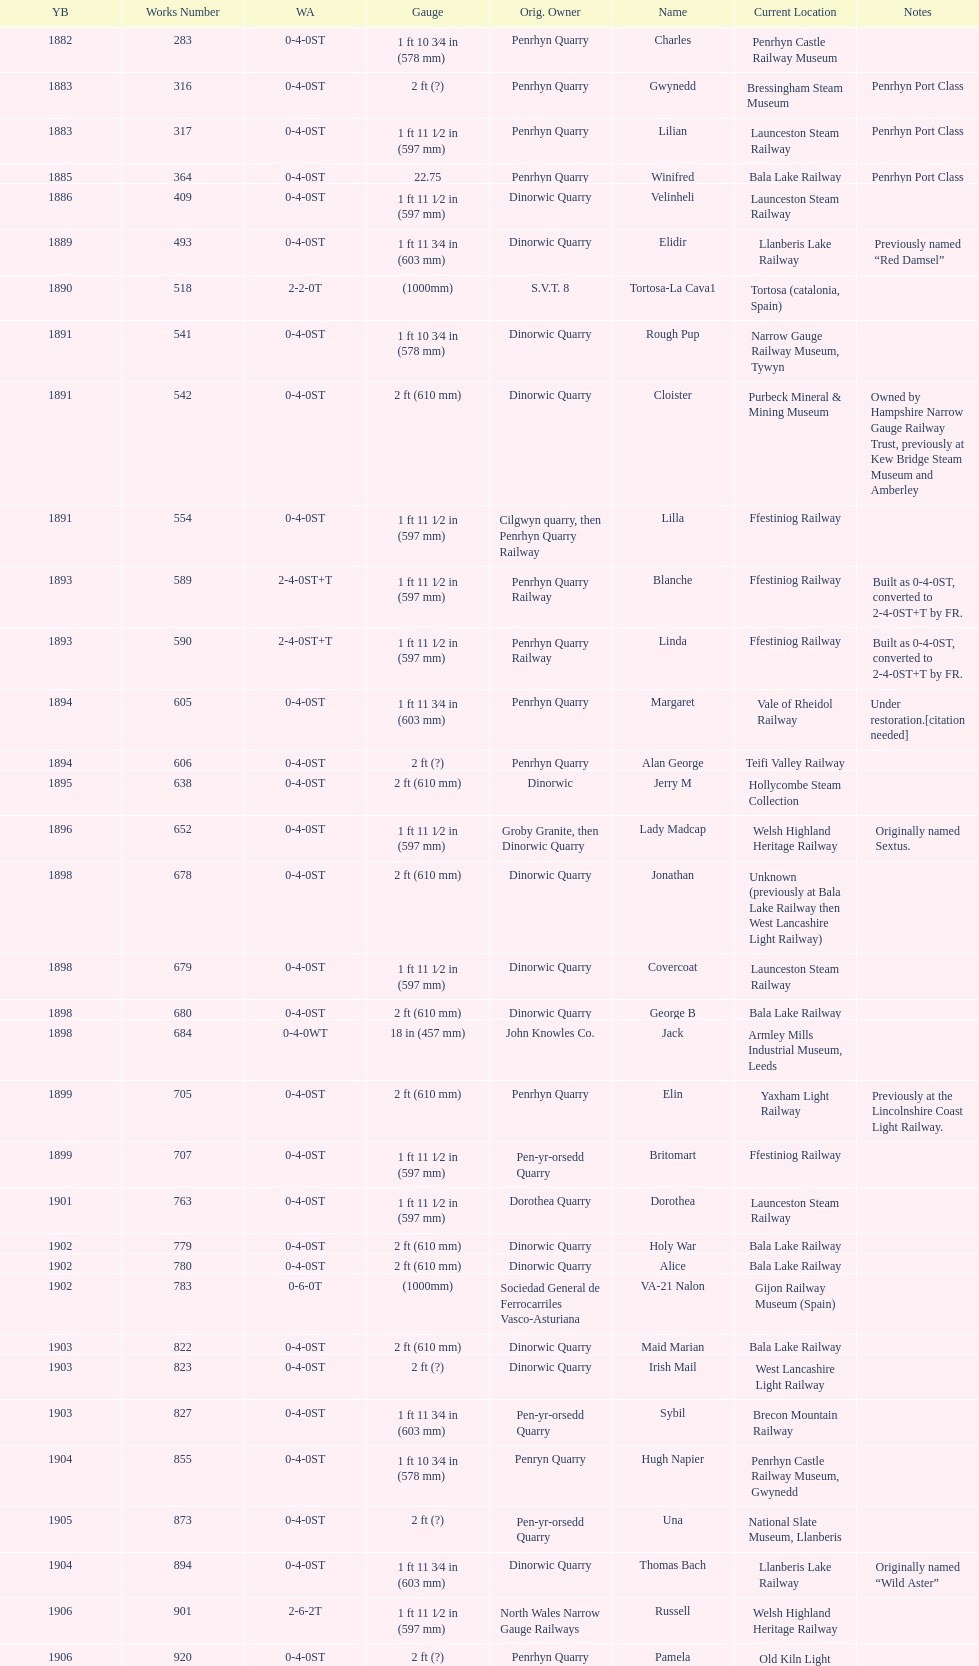What is the working number of the unique piece created in 1882? 283. 